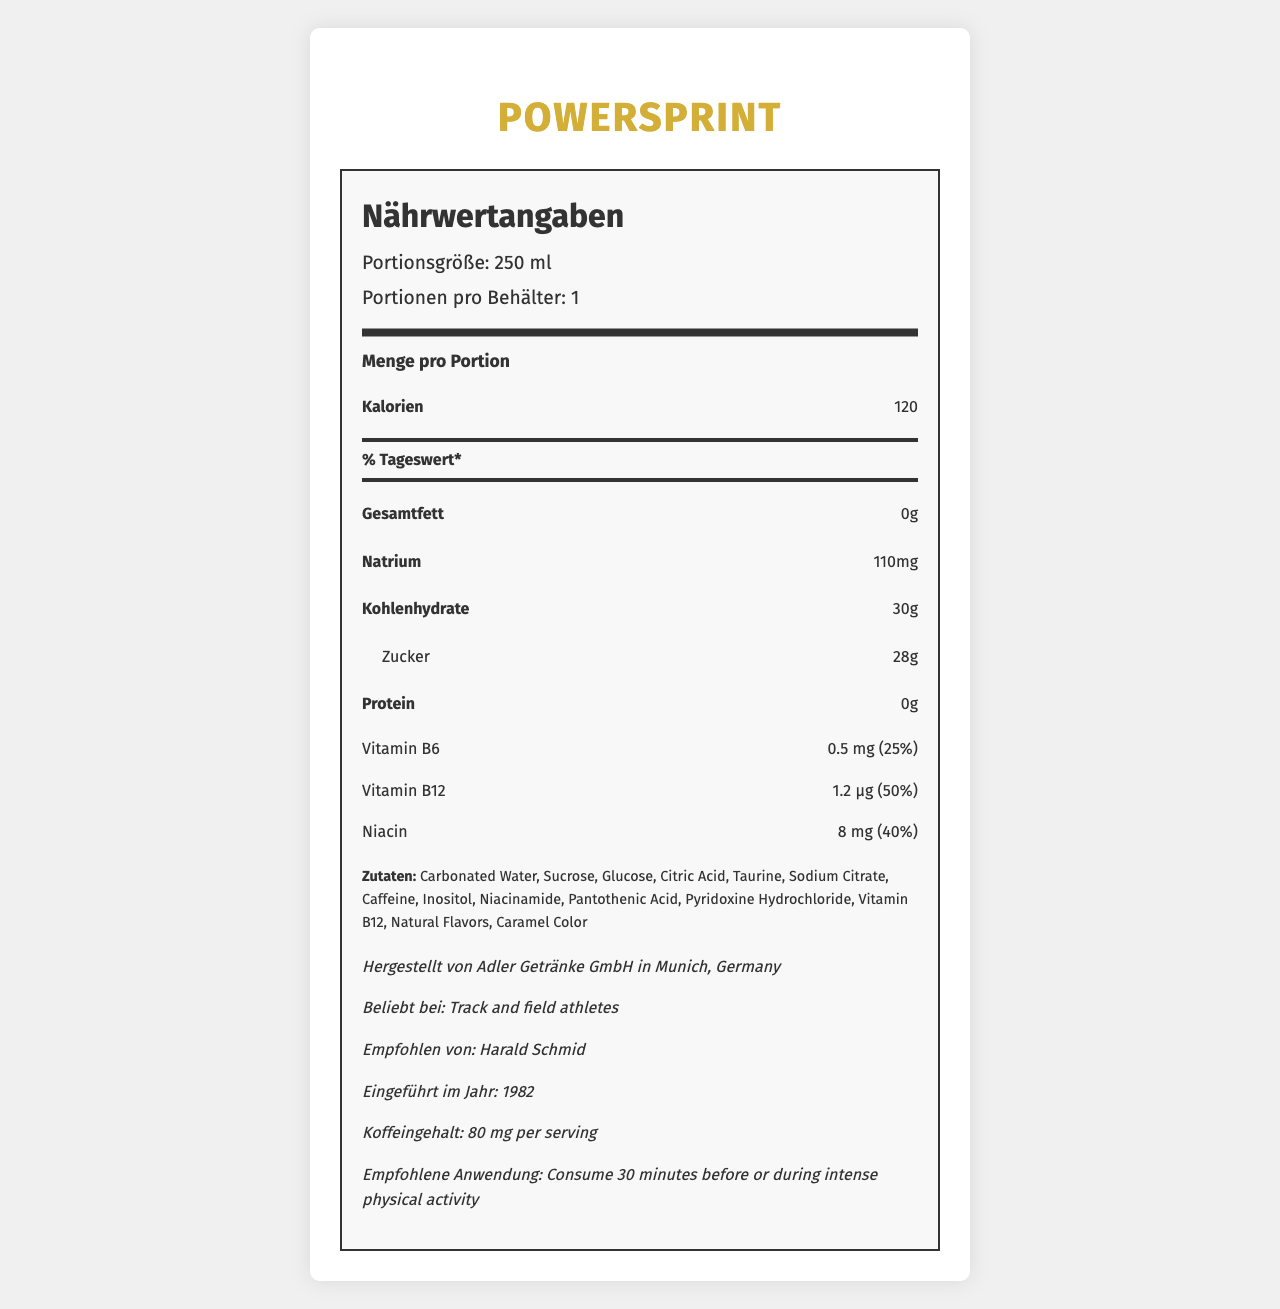what is the serving size of PowerSprint? The serving size is explicitly stated as "Portionsgröße: 250 ml" in the document.
Answer: 250 ml how many calories are there per serving? The document states "Kalorien: 120" under the "Amount per serving" section.
Answer: 120 name one vitamin found in PowerSprint and its daily value percentage. The document lists Vitamin B6 with an amount of 0.5 mg, which corresponds to 25% of the daily value.
Answer: Vitamin B6, 25% how much protein does PowerSprint contain per serving? The document mentions "Protein: 0g" under the nutrient section.
Answer: 0 g who endorses PowerSprint according to the document? The additional information section indicates "Empfohlen von: Harald Schmid".
Answer: Harald Schmid What is the sodium content in PowerSprint? The document states "Natrium: 110mg" in the nutrient section.
Answer: 110 mg What year was PowerSprint introduced? The additional information section specifies "Eingeführt im Jahr: 1982".
Answer: 1982 What type of athletes is PowerSprint popular among? A. Swimmers B. Track and field athletes C. Cyclists D. Weightlifters The additional information section states "Beliebt bei: Track and field athletes."
Answer: B. Track and field athletes Where is PowerSprint manufactured? A. Berlin B. Hamburg C. Munich D. Frankfurt The document specifies "Hergestellt von Adler Getränke GmbH in Munich, Germany."
Answer: C. Munich Does PowerSprint contain caffeine? Under additional information, it states "Koffeingehalt: 80 mg per serving."
Answer: Yes Summarize the main idea of the PowerSprint nutrition document. The main idea encompasses all key elements of the document, including the product name, nutrients, vitamins, ingredients, manufacturing details, and usage recommendations.
Answer: PowerSprint is a sports energy drink introduced in 1982, popular among track and field athletes, and endorsed by Harald Schmid. It contains various nutrients like Vitamin B6, Vitamin B12, and Niacin, packaged in a 250 ml serving with 120 calories, 0 g of fat, 110 mg of sodium, 30 g of carbohydrates, 28 g of sugars, and 80 mg of caffeine. Manufactured by Adler Getränke GmbH in Munich, it is recommended for consumption 30 minutes before or during intense physical activity. which type of athlete was Klaus Plohghaus? The document does not provide any information about Klaus Plohghaus.
Answer: I don't know What is the recommended use of PowerSprint? The additional information section advises "Empfohlene Anwendung: Consume 30 minutes before or during intense physical activity."
Answer: Consume 30 minutes before or during intense physical activity How many grams of total carbohydrates are in one serving of PowerSprint? The document states "Kohlenhydrate: 30g" in the nutrient section.
Answer: 30 g How much sugar does PowerSprint contain per serving? A. 10g B. 15g C. 20g D. 28g The nutrient section states "Zucker: 28g" under carbohydrates.
Answer: D. 28g 